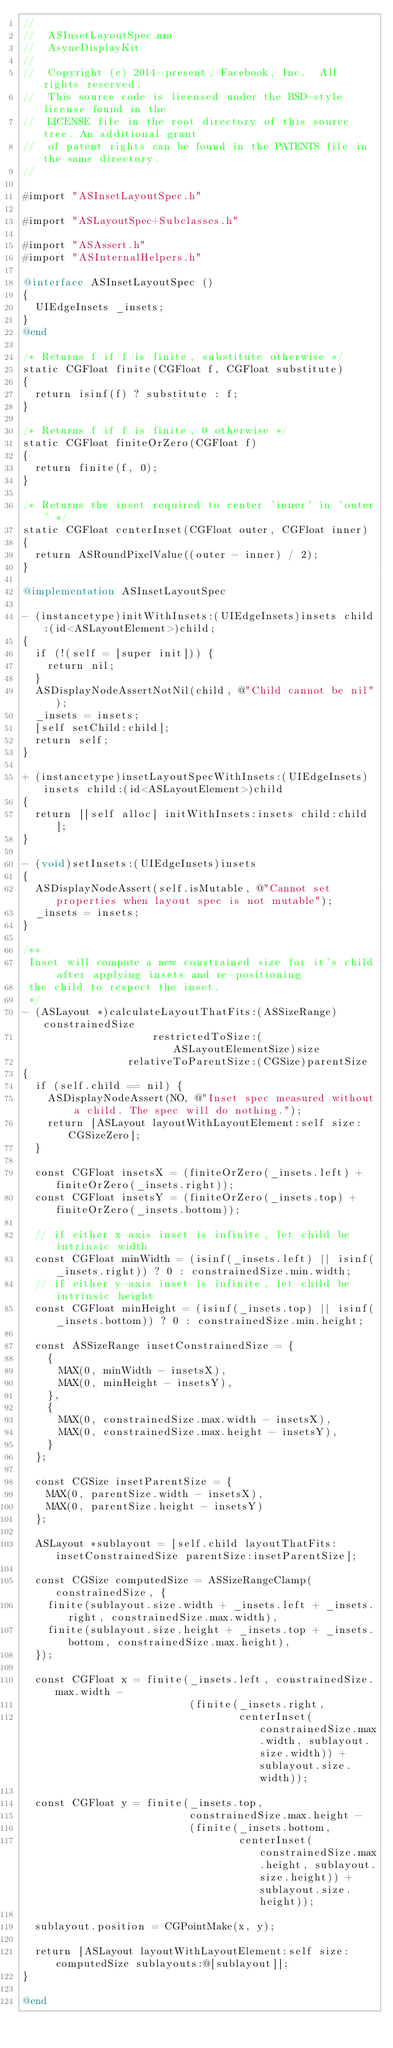Convert code to text. <code><loc_0><loc_0><loc_500><loc_500><_ObjectiveC_>//
//  ASInsetLayoutSpec.mm
//  AsyncDisplayKit
//
//  Copyright (c) 2014-present, Facebook, Inc.  All rights reserved.
//  This source code is licensed under the BSD-style license found in the
//  LICENSE file in the root directory of this source tree. An additional grant
//  of patent rights can be found in the PATENTS file in the same directory.
//

#import "ASInsetLayoutSpec.h"

#import "ASLayoutSpec+Subclasses.h"

#import "ASAssert.h"
#import "ASInternalHelpers.h"

@interface ASInsetLayoutSpec ()
{
  UIEdgeInsets _insets;
}
@end

/* Returns f if f is finite, substitute otherwise */
static CGFloat finite(CGFloat f, CGFloat substitute)
{
  return isinf(f) ? substitute : f;
}

/* Returns f if f is finite, 0 otherwise */
static CGFloat finiteOrZero(CGFloat f)
{
  return finite(f, 0);
}

/* Returns the inset required to center 'inner' in 'outer' */
static CGFloat centerInset(CGFloat outer, CGFloat inner)
{
  return ASRoundPixelValue((outer - inner) / 2);
}

@implementation ASInsetLayoutSpec

- (instancetype)initWithInsets:(UIEdgeInsets)insets child:(id<ASLayoutElement>)child;
{
  if (!(self = [super init])) {
    return nil;
  }
  ASDisplayNodeAssertNotNil(child, @"Child cannot be nil");
  _insets = insets;
  [self setChild:child];
  return self;
}

+ (instancetype)insetLayoutSpecWithInsets:(UIEdgeInsets)insets child:(id<ASLayoutElement>)child
{
  return [[self alloc] initWithInsets:insets child:child];
}

- (void)setInsets:(UIEdgeInsets)insets
{
  ASDisplayNodeAssert(self.isMutable, @"Cannot set properties when layout spec is not mutable");
  _insets = insets;
}

/**
 Inset will compute a new constrained size for it's child after applying insets and re-positioning
 the child to respect the inset.
 */
- (ASLayout *)calculateLayoutThatFits:(ASSizeRange)constrainedSize
                     restrictedToSize:(ASLayoutElementSize)size
                 relativeToParentSize:(CGSize)parentSize
{
  if (self.child == nil) {
    ASDisplayNodeAssert(NO, @"Inset spec measured without a child. The spec will do nothing.");
    return [ASLayout layoutWithLayoutElement:self size:CGSizeZero];
  }
  
  const CGFloat insetsX = (finiteOrZero(_insets.left) + finiteOrZero(_insets.right));
  const CGFloat insetsY = (finiteOrZero(_insets.top) + finiteOrZero(_insets.bottom));

  // if either x-axis inset is infinite, let child be intrinsic width
  const CGFloat minWidth = (isinf(_insets.left) || isinf(_insets.right)) ? 0 : constrainedSize.min.width;
  // if either y-axis inset is infinite, let child be intrinsic height
  const CGFloat minHeight = (isinf(_insets.top) || isinf(_insets.bottom)) ? 0 : constrainedSize.min.height;

  const ASSizeRange insetConstrainedSize = {
    {
      MAX(0, minWidth - insetsX),
      MAX(0, minHeight - insetsY),
    },
    {
      MAX(0, constrainedSize.max.width - insetsX),
      MAX(0, constrainedSize.max.height - insetsY),
    }
  };
  
  const CGSize insetParentSize = {
    MAX(0, parentSize.width - insetsX),
    MAX(0, parentSize.height - insetsY)
  };
  
  ASLayout *sublayout = [self.child layoutThatFits:insetConstrainedSize parentSize:insetParentSize];

  const CGSize computedSize = ASSizeRangeClamp(constrainedSize, {
    finite(sublayout.size.width + _insets.left + _insets.right, constrainedSize.max.width),
    finite(sublayout.size.height + _insets.top + _insets.bottom, constrainedSize.max.height),
  });

  const CGFloat x = finite(_insets.left, constrainedSize.max.width -
                           (finite(_insets.right,
                                   centerInset(constrainedSize.max.width, sublayout.size.width)) + sublayout.size.width));

  const CGFloat y = finite(_insets.top,
                           constrainedSize.max.height -
                           (finite(_insets.bottom,
                                   centerInset(constrainedSize.max.height, sublayout.size.height)) + sublayout.size.height));
  
  sublayout.position = CGPointMake(x, y);
  
  return [ASLayout layoutWithLayoutElement:self size:computedSize sublayouts:@[sublayout]];
}

@end
</code> 